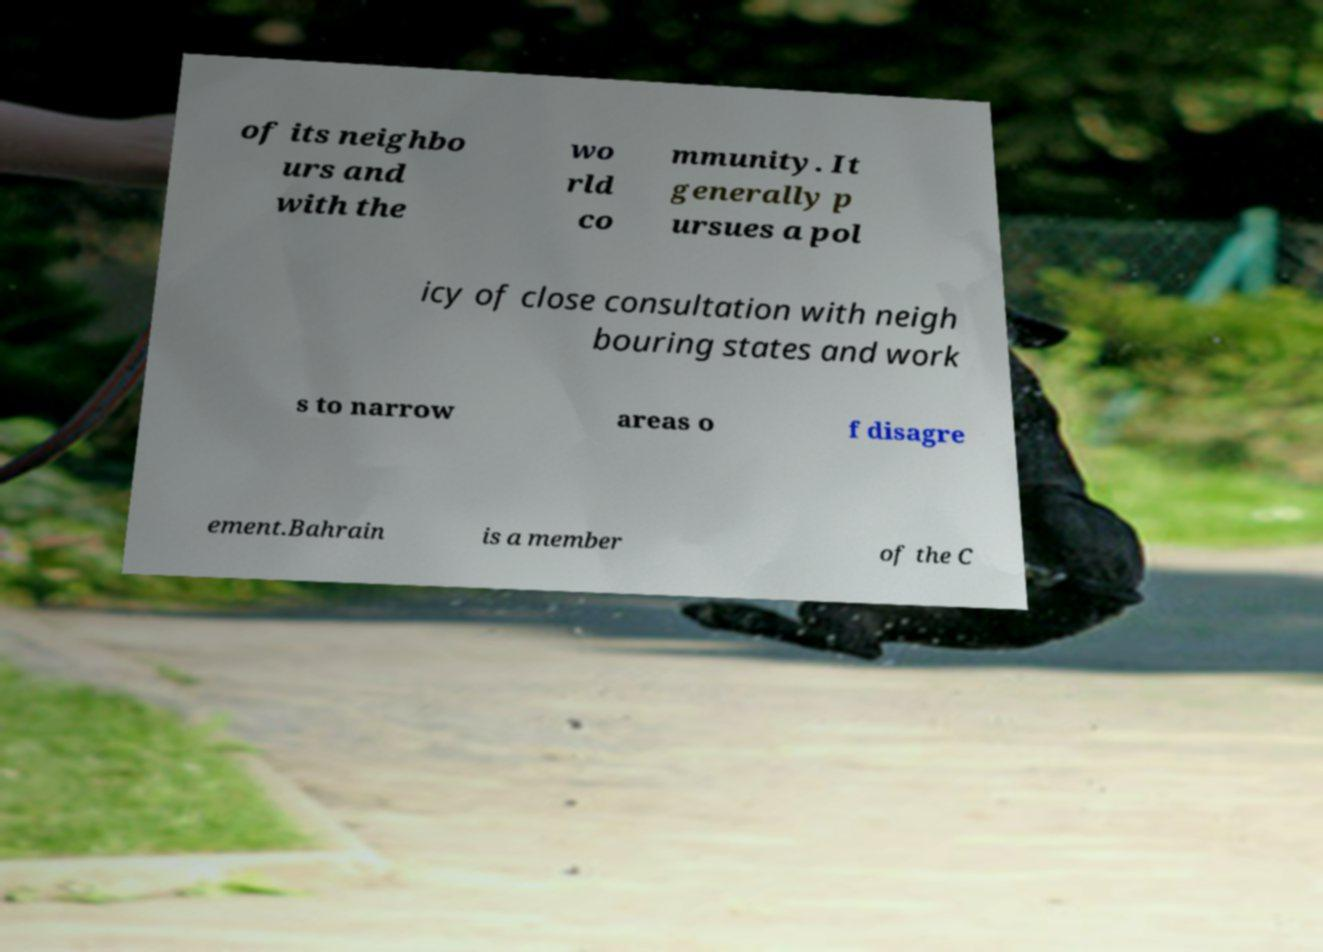I need the written content from this picture converted into text. Can you do that? of its neighbo urs and with the wo rld co mmunity. It generally p ursues a pol icy of close consultation with neigh bouring states and work s to narrow areas o f disagre ement.Bahrain is a member of the C 